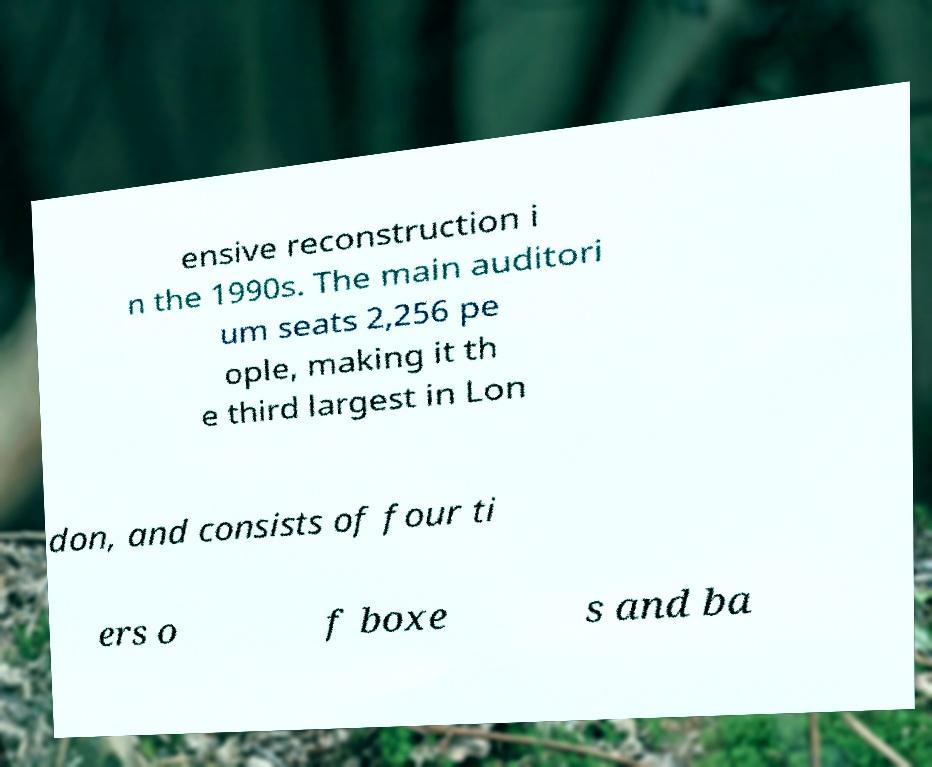Could you extract and type out the text from this image? ensive reconstruction i n the 1990s. The main auditori um seats 2,256 pe ople, making it th e third largest in Lon don, and consists of four ti ers o f boxe s and ba 